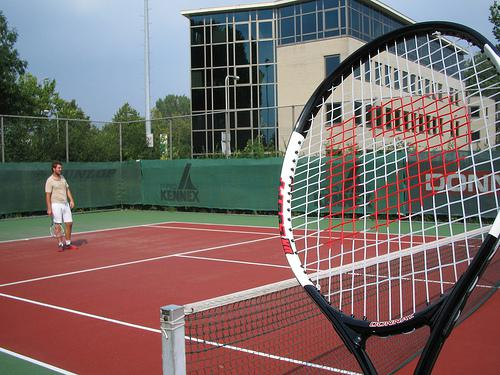Question: who is playing tennis?
Choices:
A. A man.
B. A woman.
C. A boy.
D. A girl.
Answer with the letter. Answer: A Question: why is the man holding a racket?
Choices:
A. To play tennis.
B. To play racqetball.
C. To hit bees.
D. Practicing his backhand.
Answer with the letter. Answer: A Question: what is the color of the fence?
Choices:
A. Silver.
B. Blue.
C. Brown.
D. Green.
Answer with the letter. Answer: D Question: what is the color of the tennis court?
Choices:
A. Green.
B. Green and orange.
C. Brown.
D. Black.
Answer with the letter. Answer: B Question: where is the player?
Choices:
A. On the basketball court.
B. On the baseball field.
C. In the tennis court.
D. On the football field.
Answer with the letter. Answer: C 